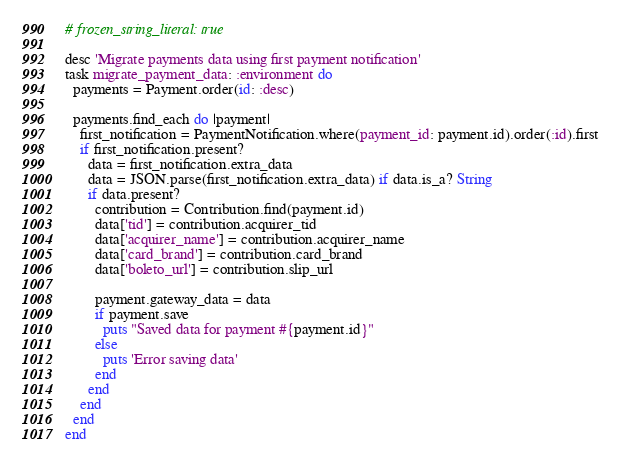<code> <loc_0><loc_0><loc_500><loc_500><_Ruby_># frozen_string_literal: true

desc 'Migrate payments data using first payment notification'
task migrate_payment_data: :environment do
  payments = Payment.order(id: :desc)

  payments.find_each do |payment|
    first_notification = PaymentNotification.where(payment_id: payment.id).order(:id).first
    if first_notification.present?
      data = first_notification.extra_data
      data = JSON.parse(first_notification.extra_data) if data.is_a? String
      if data.present?
        contribution = Contribution.find(payment.id)
        data['tid'] = contribution.acquirer_tid
        data['acquirer_name'] = contribution.acquirer_name
        data['card_brand'] = contribution.card_brand
        data['boleto_url'] = contribution.slip_url

        payment.gateway_data = data
        if payment.save
          puts "Saved data for payment #{payment.id}"
        else
          puts 'Error saving data'
        end
      end
    end
  end
end
</code> 